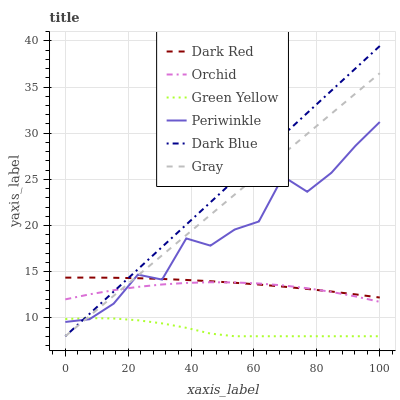Does Green Yellow have the minimum area under the curve?
Answer yes or no. Yes. Does Dark Blue have the maximum area under the curve?
Answer yes or no. Yes. Does Dark Red have the minimum area under the curve?
Answer yes or no. No. Does Dark Red have the maximum area under the curve?
Answer yes or no. No. Is Dark Blue the smoothest?
Answer yes or no. Yes. Is Periwinkle the roughest?
Answer yes or no. Yes. Is Dark Red the smoothest?
Answer yes or no. No. Is Dark Red the roughest?
Answer yes or no. No. Does Dark Red have the lowest value?
Answer yes or no. No. Does Dark Blue have the highest value?
Answer yes or no. Yes. Does Dark Red have the highest value?
Answer yes or no. No. Is Green Yellow less than Orchid?
Answer yes or no. Yes. Is Orchid greater than Green Yellow?
Answer yes or no. Yes. Does Periwinkle intersect Dark Blue?
Answer yes or no. Yes. Is Periwinkle less than Dark Blue?
Answer yes or no. No. Is Periwinkle greater than Dark Blue?
Answer yes or no. No. Does Green Yellow intersect Orchid?
Answer yes or no. No. 